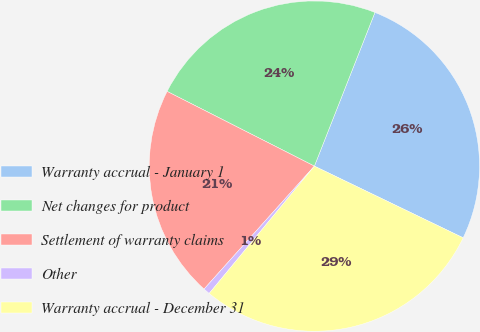Convert chart. <chart><loc_0><loc_0><loc_500><loc_500><pie_chart><fcel>Warranty accrual - January 1<fcel>Net changes for product<fcel>Settlement of warranty claims<fcel>Other<fcel>Warranty accrual - December 31<nl><fcel>26.17%<fcel>23.5%<fcel>20.83%<fcel>0.65%<fcel>28.84%<nl></chart> 